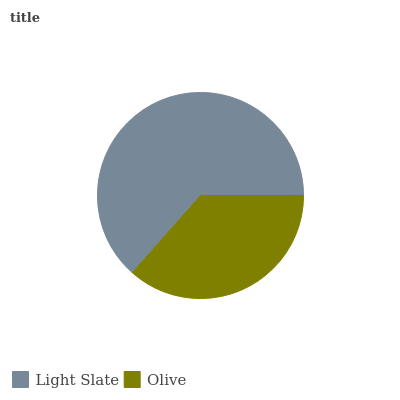Is Olive the minimum?
Answer yes or no. Yes. Is Light Slate the maximum?
Answer yes or no. Yes. Is Olive the maximum?
Answer yes or no. No. Is Light Slate greater than Olive?
Answer yes or no. Yes. Is Olive less than Light Slate?
Answer yes or no. Yes. Is Olive greater than Light Slate?
Answer yes or no. No. Is Light Slate less than Olive?
Answer yes or no. No. Is Light Slate the high median?
Answer yes or no. Yes. Is Olive the low median?
Answer yes or no. Yes. Is Olive the high median?
Answer yes or no. No. Is Light Slate the low median?
Answer yes or no. No. 